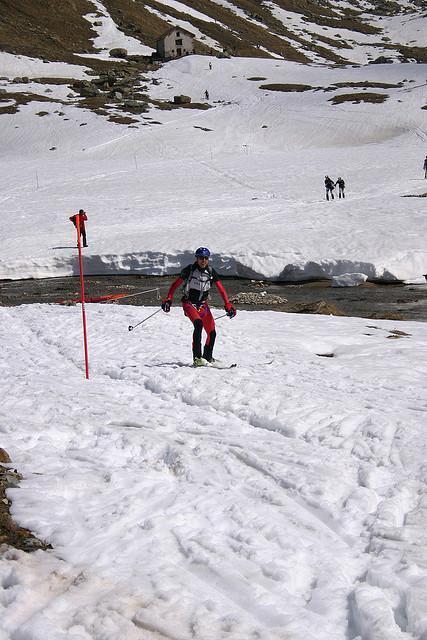How many people are out there?
Give a very brief answer. 3. How many bowls in the image contain broccoli?
Give a very brief answer. 0. 